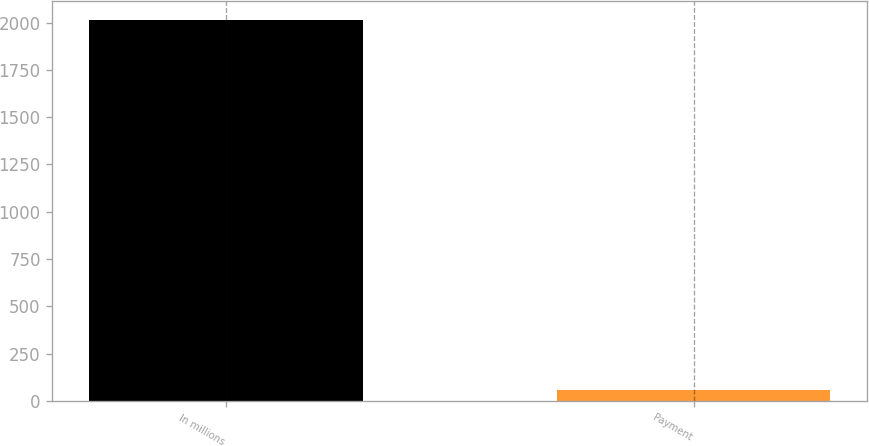Convert chart. <chart><loc_0><loc_0><loc_500><loc_500><bar_chart><fcel>In millions<fcel>Payment<nl><fcel>2013<fcel>61<nl></chart> 